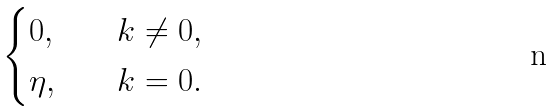Convert formula to latex. <formula><loc_0><loc_0><loc_500><loc_500>\begin{cases} 0 , & \quad k \ne 0 , \\ \eta , & \quad k = 0 . \end{cases}</formula> 